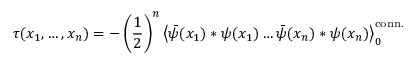Convert formula to latex. <formula><loc_0><loc_0><loc_500><loc_500>\tau ( x _ { 1 } , \dots , x _ { n } ) = - \left ( \frac { 1 } { 2 } \right ) ^ { n } \left < \bar { \psi } ( x _ { 1 } ) * \psi ( x _ { 1 } ) \dots \bar { \psi } ( x _ { n } ) * \psi ( x _ { n } ) \right > _ { 0 } ^ { c o n n . }</formula> 